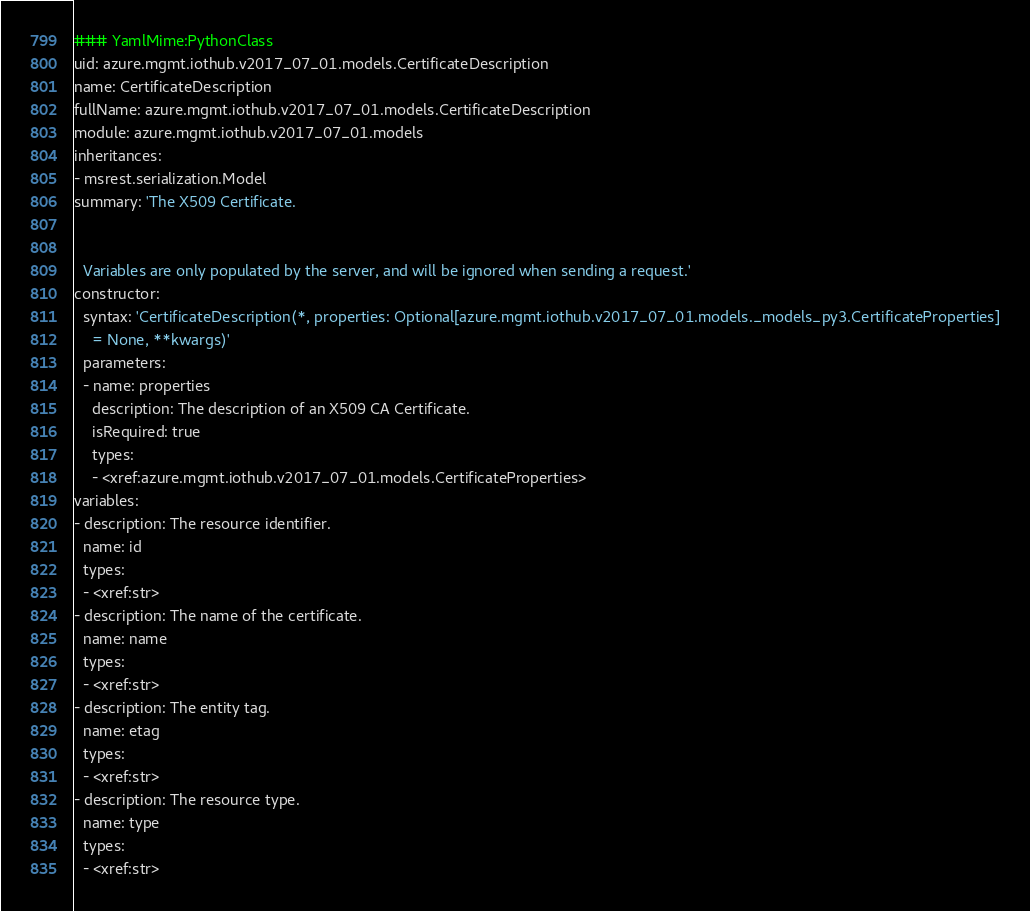<code> <loc_0><loc_0><loc_500><loc_500><_YAML_>### YamlMime:PythonClass
uid: azure.mgmt.iothub.v2017_07_01.models.CertificateDescription
name: CertificateDescription
fullName: azure.mgmt.iothub.v2017_07_01.models.CertificateDescription
module: azure.mgmt.iothub.v2017_07_01.models
inheritances:
- msrest.serialization.Model
summary: 'The X509 Certificate.


  Variables are only populated by the server, and will be ignored when sending a request.'
constructor:
  syntax: 'CertificateDescription(*, properties: Optional[azure.mgmt.iothub.v2017_07_01.models._models_py3.CertificateProperties]
    = None, **kwargs)'
  parameters:
  - name: properties
    description: The description of an X509 CA Certificate.
    isRequired: true
    types:
    - <xref:azure.mgmt.iothub.v2017_07_01.models.CertificateProperties>
variables:
- description: The resource identifier.
  name: id
  types:
  - <xref:str>
- description: The name of the certificate.
  name: name
  types:
  - <xref:str>
- description: The entity tag.
  name: etag
  types:
  - <xref:str>
- description: The resource type.
  name: type
  types:
  - <xref:str>
</code> 